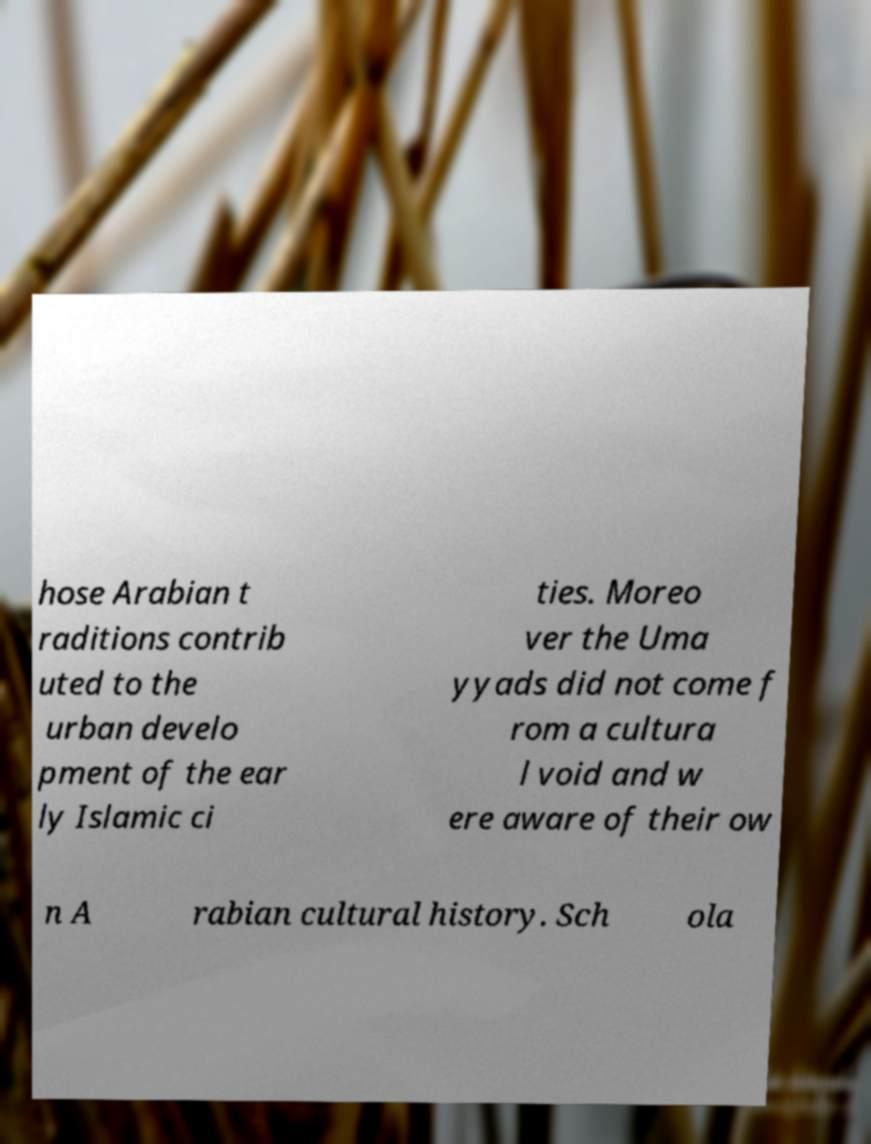Could you assist in decoding the text presented in this image and type it out clearly? hose Arabian t raditions contrib uted to the urban develo pment of the ear ly Islamic ci ties. Moreo ver the Uma yyads did not come f rom a cultura l void and w ere aware of their ow n A rabian cultural history. Sch ola 